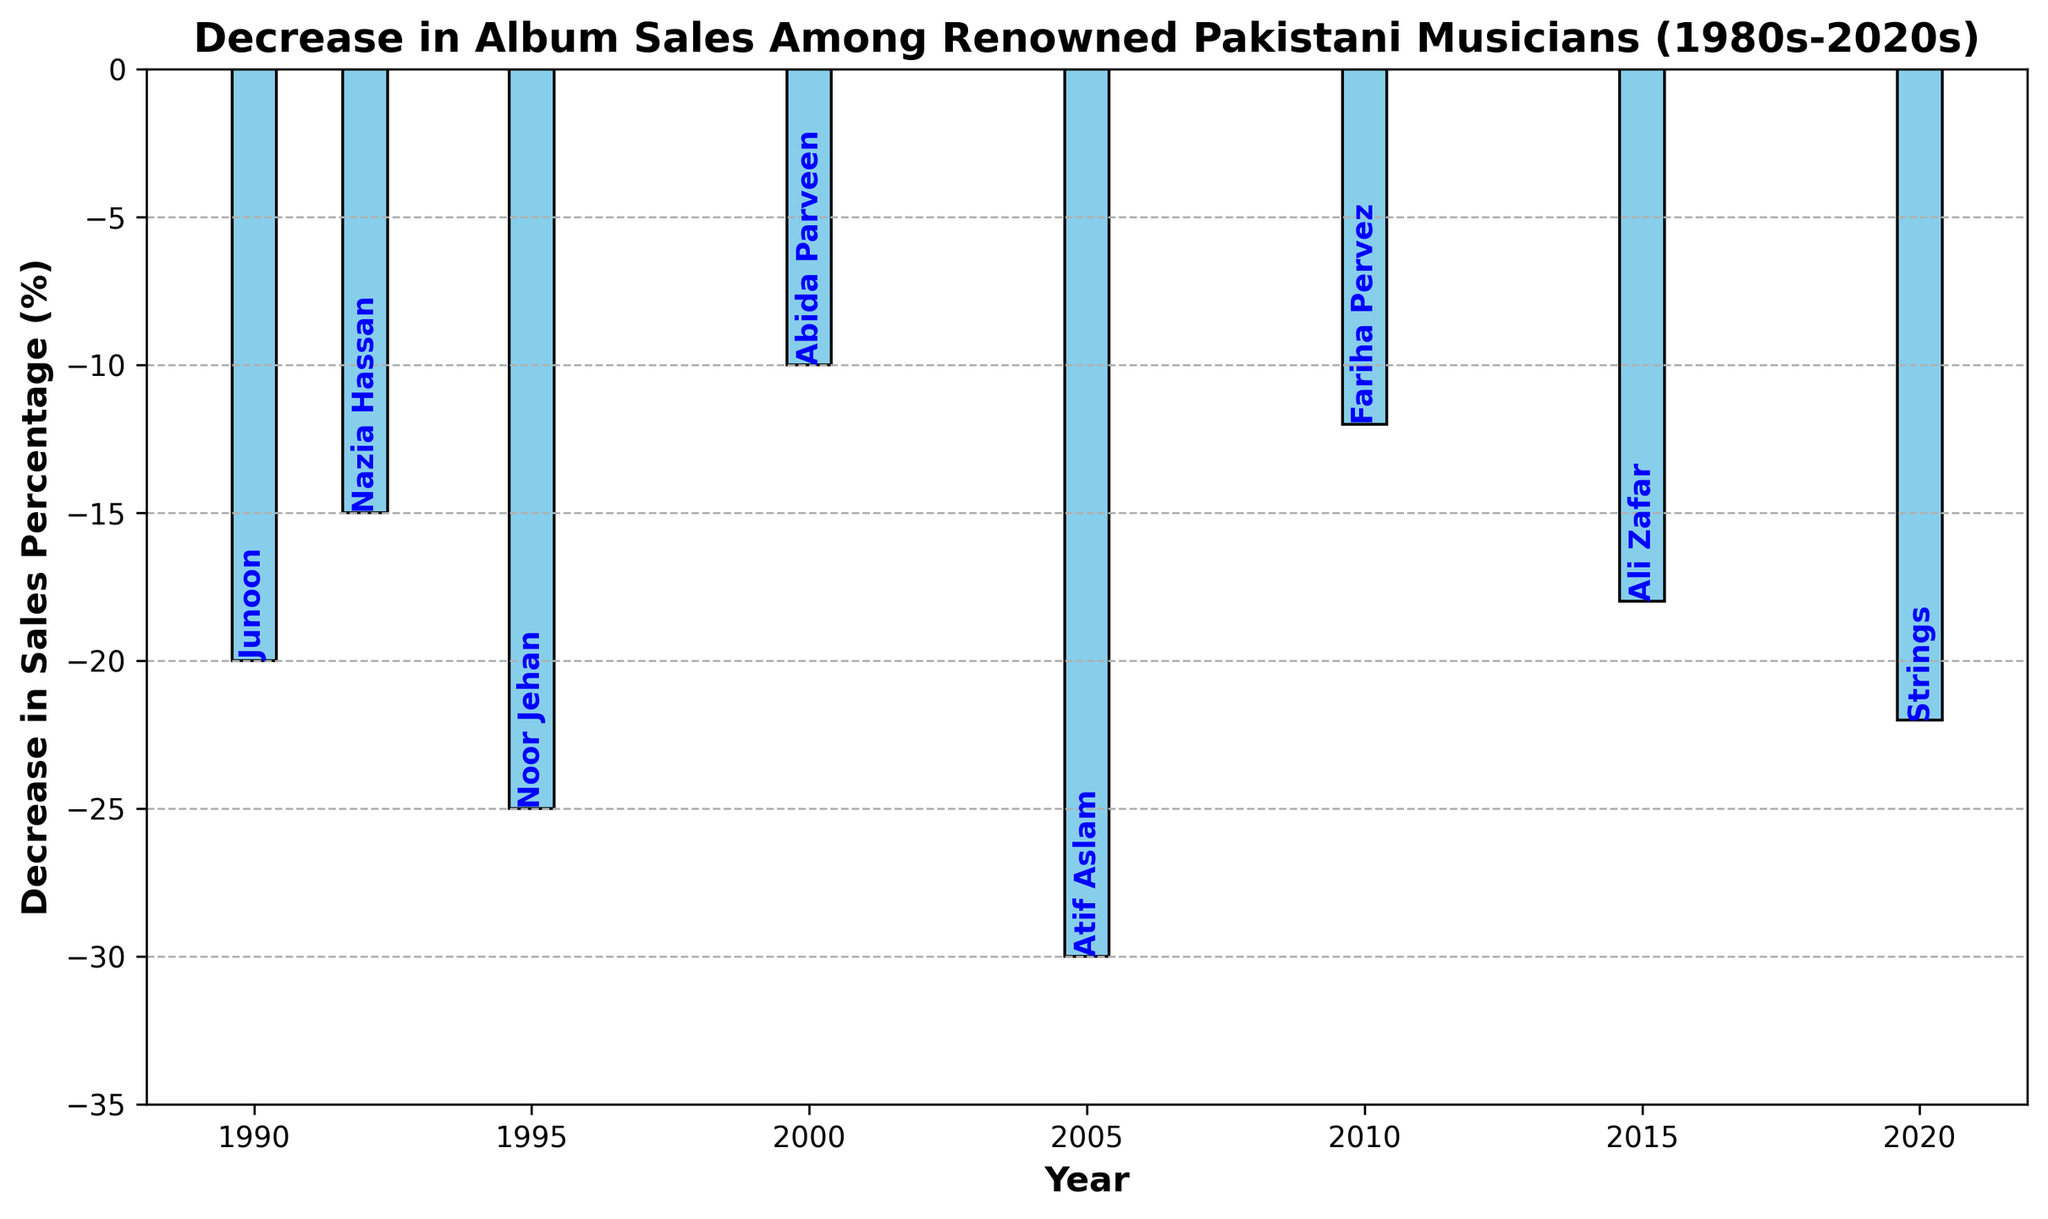Which artist experienced the greatest decrease in album sales? Based on the height of the bars, Atif Aslam experienced the greatest decrease in album sales percentage, as his bar reaches the lowest point at -30%.
Answer: Atif Aslam Which years saw a decrease in album sales of at least 20%? The bars for the years 1990 (Junoon), 1995 (Noor Jehan), 2020 (Strings) show a decrease in sales of at least 20%, as both bars extend to -20%, -25%, and -22% respectively.
Answer: 1990, 1995, 2020 What was the combined decrease in album sales for the years 1995 and 2005? The bar heights for 1995 (Noor Jehan) and 2005 (Atif Aslam) show -25% and -30% respectively. Summing these two values, -25 + -30 = -55.
Answer: -55% Which artist's sales decreased by 15% and in which year did it occur? The bar annotated with "Nazia Hassan" shows a decrease of -15%, which occurred in the year 1992.
Answer: Nazia Hassan, 1992 Was the decrease in album sales for Ali Zafar greater or less than the decrease for Fariha Pervez? By comparing the heights of the bars, Ali Zafar saw a decrease of -18%, while Fariha Pervez saw a decrease of -12%. Hence, Ali Zafar's decrease was greater.
Answer: Greater How does the decrease in album sales for Junoon compare to that of Strings? The bar for Junoon in 1990 shows a decrease of -20%, while the bar for Strings in 2020 shows -22%. Therefore, Strings experienced a slightly greater decrease than Junoon.
Answer: Strings had a greater decrease What is the average decrease in sales percentage across all the years presented? Adding all the decreases: -20 (Junoon) + -15 (Nazia Hassan) + -25 (Noor Jehan) + -10 (Abida Parveen) + -30 (Atif Aslam) + -12 (Fariha Pervez) + -18 (Ali Zafar) + -22 (Strings) = -152. There are 8 data points, so the average is -152 / 8 = -19%.
Answer: -19% Which artist had a smaller decrease in album sales, Abida Parveen or Ali Zafar? The bar for Abida Parveen in 2000 shows a decrease of -10%, while the bar for Ali Zafar in 2015 shows a decrease of -18%. Thus, Abida Parveen had a smaller decrease.
Answer: Abida Parveen How much higher was Abida Parveen's decrease in sales compared to Fariha Pervez's? The bar for Abida Parveen shows -10% and for Fariha Pervez shows -12%. To find the difference: -12 - (-10) = -2.
Answer: 2% higher for Fariha Pervez 